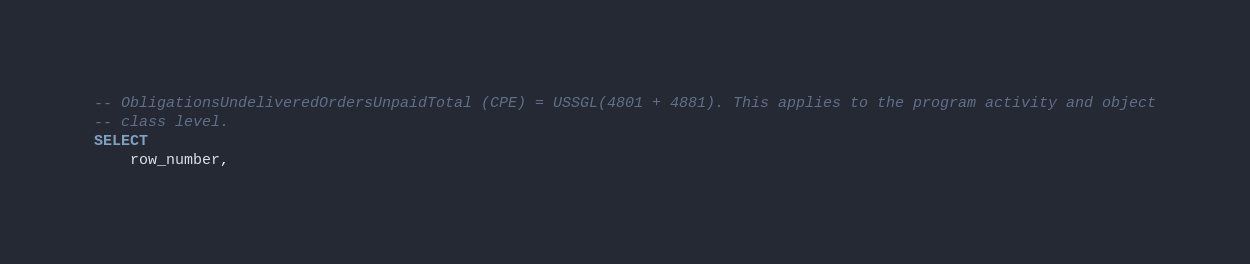Convert code to text. <code><loc_0><loc_0><loc_500><loc_500><_SQL_>-- ObligationsUndeliveredOrdersUnpaidTotal (CPE) = USSGL(4801 + 4881). This applies to the program activity and object
-- class level.
SELECT
    row_number,</code> 